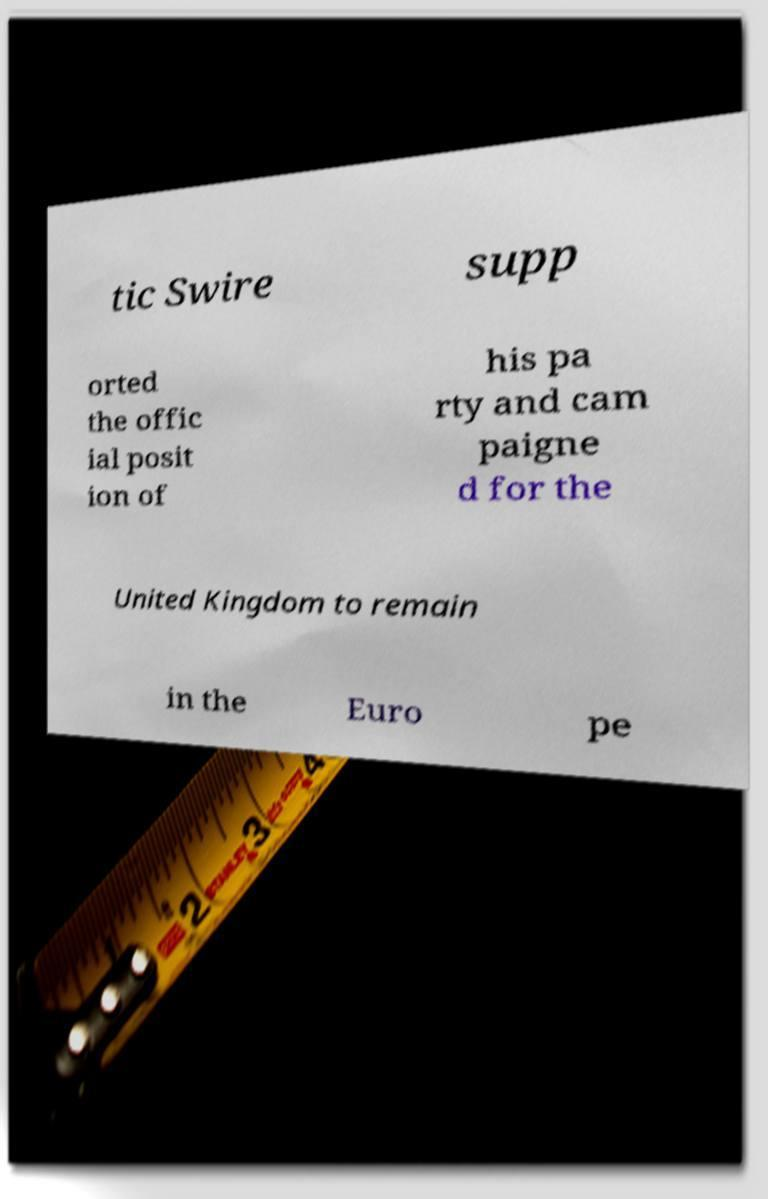Please identify and transcribe the text found in this image. tic Swire supp orted the offic ial posit ion of his pa rty and cam paigne d for the United Kingdom to remain in the Euro pe 